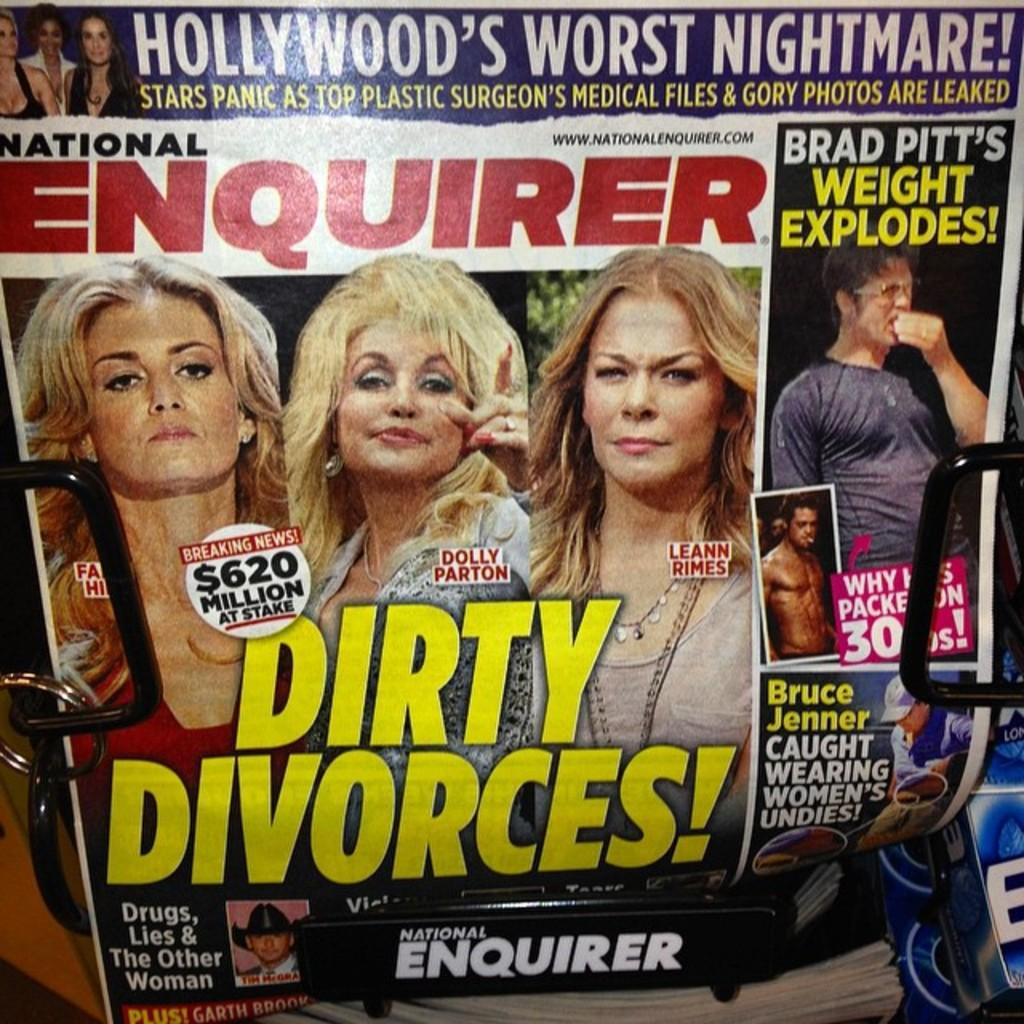What is the main subject of the poster in the image? The poster contains pictures of people. What else can be found on the poster besides the pictures? There is text on the poster. What color is the eggnog being served in the image? There is no eggnog present in the image; it only features a poster with pictures of people and text. 